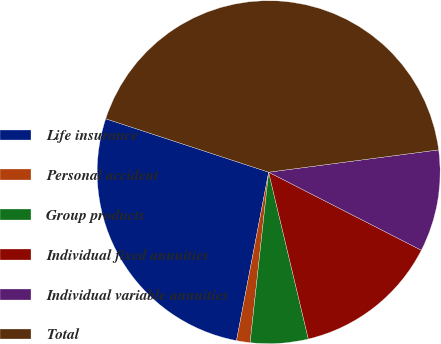Convert chart to OTSL. <chart><loc_0><loc_0><loc_500><loc_500><pie_chart><fcel>Life insurance<fcel>Personal accident<fcel>Group products<fcel>Individual fixed annuities<fcel>Individual variable annuities<fcel>Total<nl><fcel>27.04%<fcel>1.28%<fcel>5.44%<fcel>13.76%<fcel>9.6%<fcel>42.88%<nl></chart> 